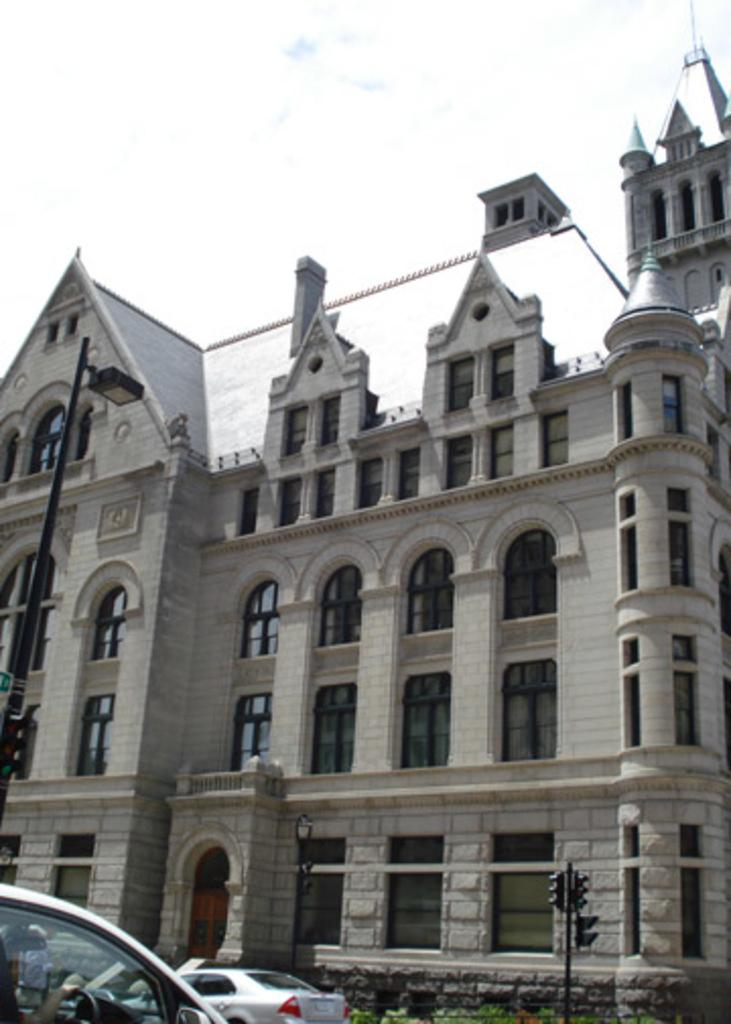What is the main subject of the image? The image is of a building. What can be seen in the foreground of the image? There are cars, plants, and a signal light in the foreground of the image. What is the weather like in the image? It is a sunny day. Are there any other light sources visible in the image? Yes, there is a street light on the right side of the image. What type of tin can be seen rolling down the slope in the image? There is no tin or slope present in the image. 